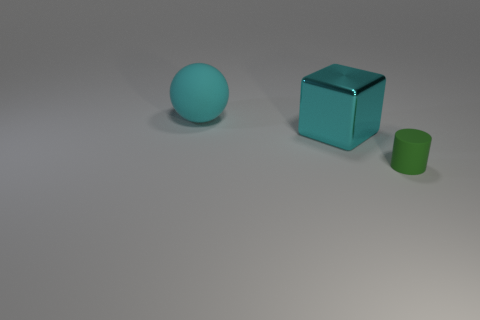Are there any other things that have the same size as the green matte thing?
Give a very brief answer. No. Is there anything else that is the same shape as the big cyan matte object?
Your answer should be compact. No. Do the large shiny block and the ball have the same color?
Provide a short and direct response. Yes. How many rubber things have the same color as the metal cube?
Offer a very short reply. 1. There is a green cylinder in front of the large metallic block; is it the same size as the matte object left of the tiny rubber cylinder?
Offer a very short reply. No. The object that is right of the big cyan thing that is to the right of the big thing to the left of the cube is what shape?
Make the answer very short. Cylinder. Are there any other things that are made of the same material as the large cube?
Your answer should be compact. No. There is a thing that is behind the matte cylinder and in front of the large ball; what is its color?
Offer a very short reply. Cyan. Do the cylinder and the large object that is to the right of the cyan rubber sphere have the same material?
Your answer should be very brief. No. Is the number of rubber things that are right of the small green thing less than the number of tiny blue rubber spheres?
Your answer should be very brief. No. 